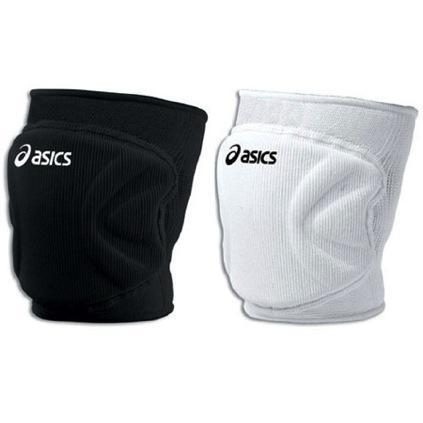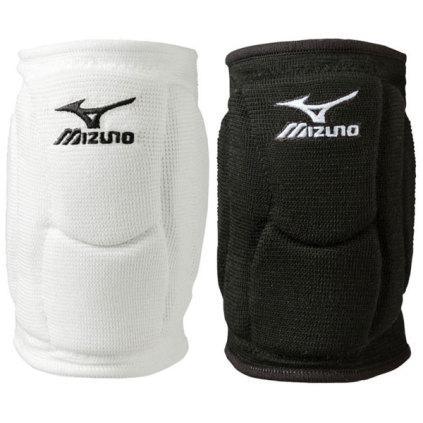The first image is the image on the left, the second image is the image on the right. For the images shown, is this caption "There is one white and one black knee brace in the left image." true? Answer yes or no. Yes. The first image is the image on the left, the second image is the image on the right. Evaluate the accuracy of this statement regarding the images: "Each image includes a black knee pad and a white knee pad.". Is it true? Answer yes or no. Yes. 